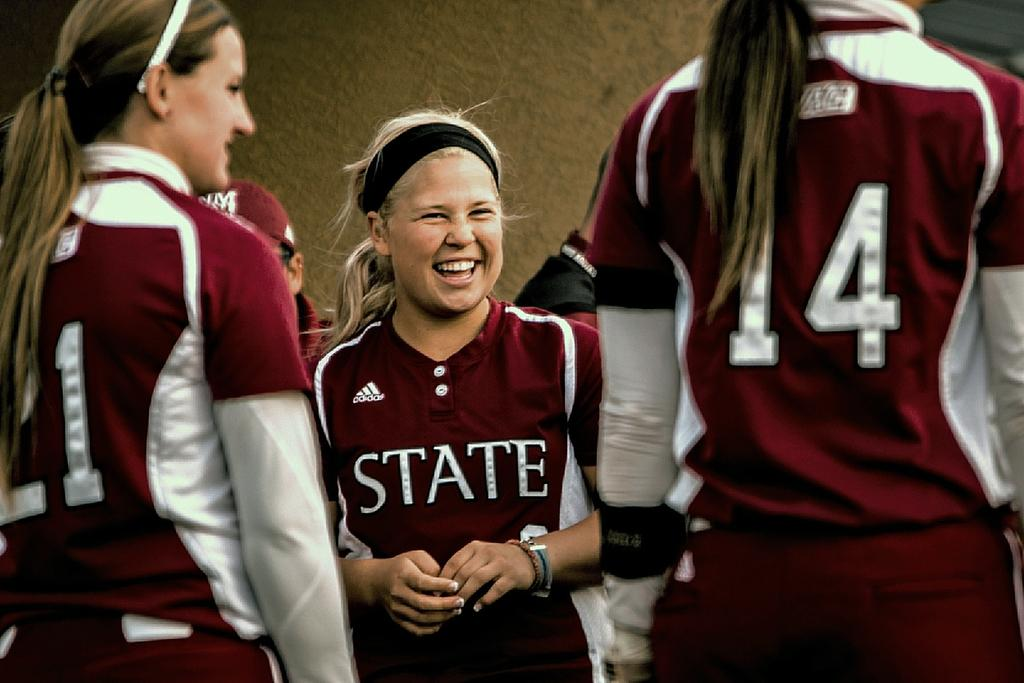<image>
Relay a brief, clear account of the picture shown. A female athlete has a red and wite shirt with the logo for state and adidas on her chest. 